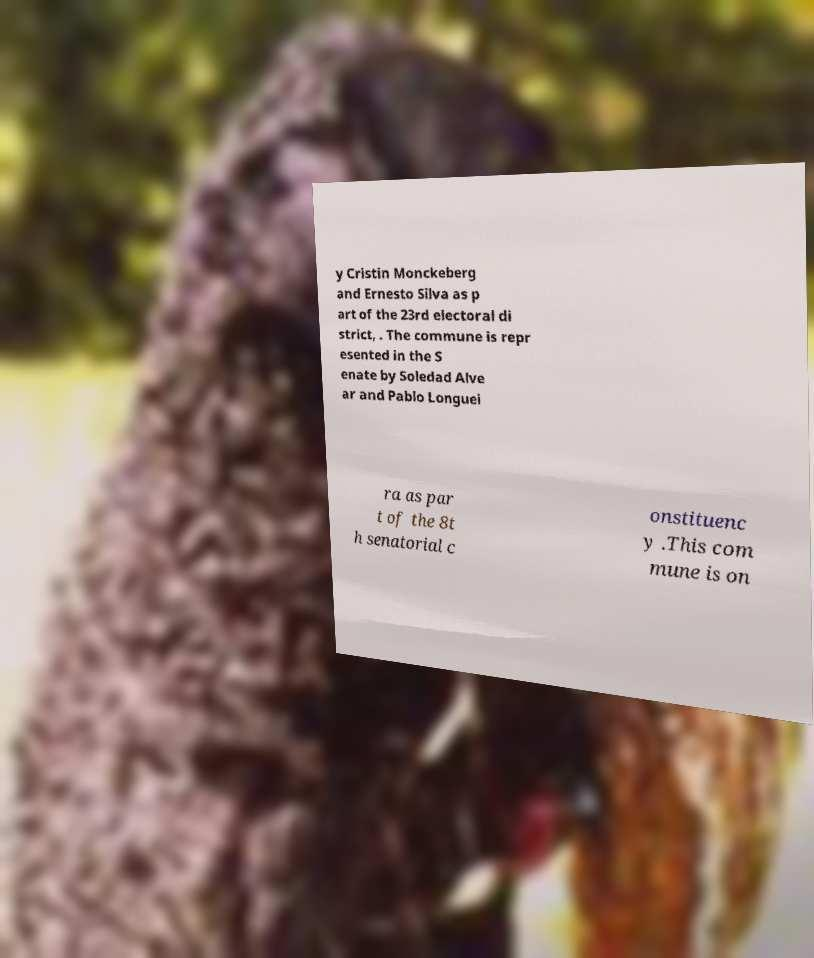I need the written content from this picture converted into text. Can you do that? y Cristin Monckeberg and Ernesto Silva as p art of the 23rd electoral di strict, . The commune is repr esented in the S enate by Soledad Alve ar and Pablo Longuei ra as par t of the 8t h senatorial c onstituenc y .This com mune is on 